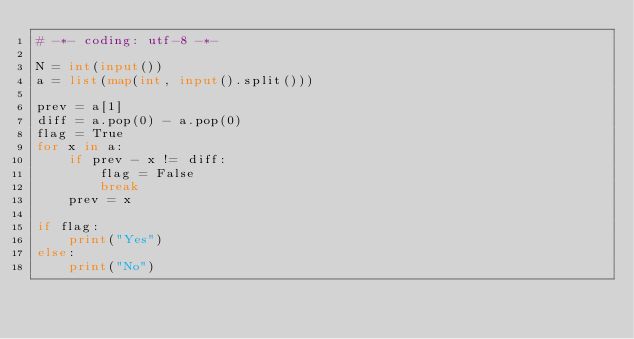Convert code to text. <code><loc_0><loc_0><loc_500><loc_500><_Python_># -*- coding: utf-8 -*-

N = int(input())
a = list(map(int, input().split()))

prev = a[1]
diff = a.pop(0) - a.pop(0)
flag = True
for x in a:
    if prev - x != diff:
        flag = False
        break
    prev = x

if flag:
    print("Yes")
else:
    print("No")</code> 